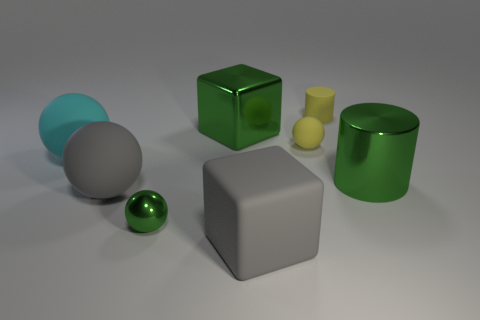How many other objects are the same shape as the cyan object? There is one other object that shares the same cylindrical shape as the cyan object, which is the green cylinder. 